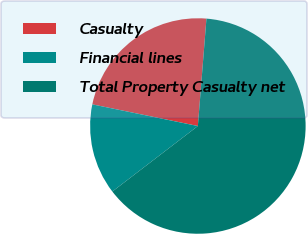<chart> <loc_0><loc_0><loc_500><loc_500><pie_chart><fcel>Casualty<fcel>Financial lines<fcel>Total Property Casualty net<nl><fcel>23.05%<fcel>13.62%<fcel>63.33%<nl></chart> 